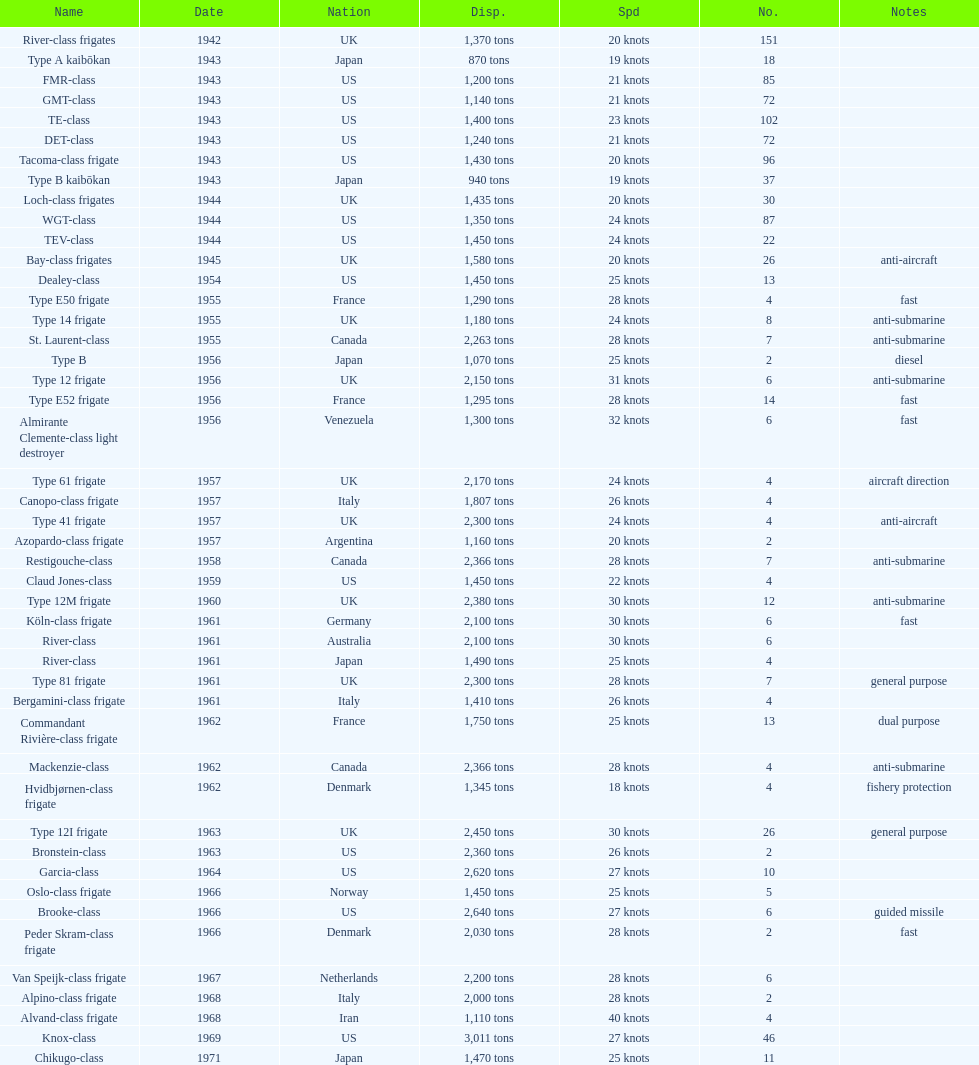How many consecutive escorts were in 1943? 7. 